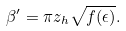Convert formula to latex. <formula><loc_0><loc_0><loc_500><loc_500>\beta ^ { \prime } = \pi z _ { h } \sqrt { f ( \epsilon ) } .</formula> 